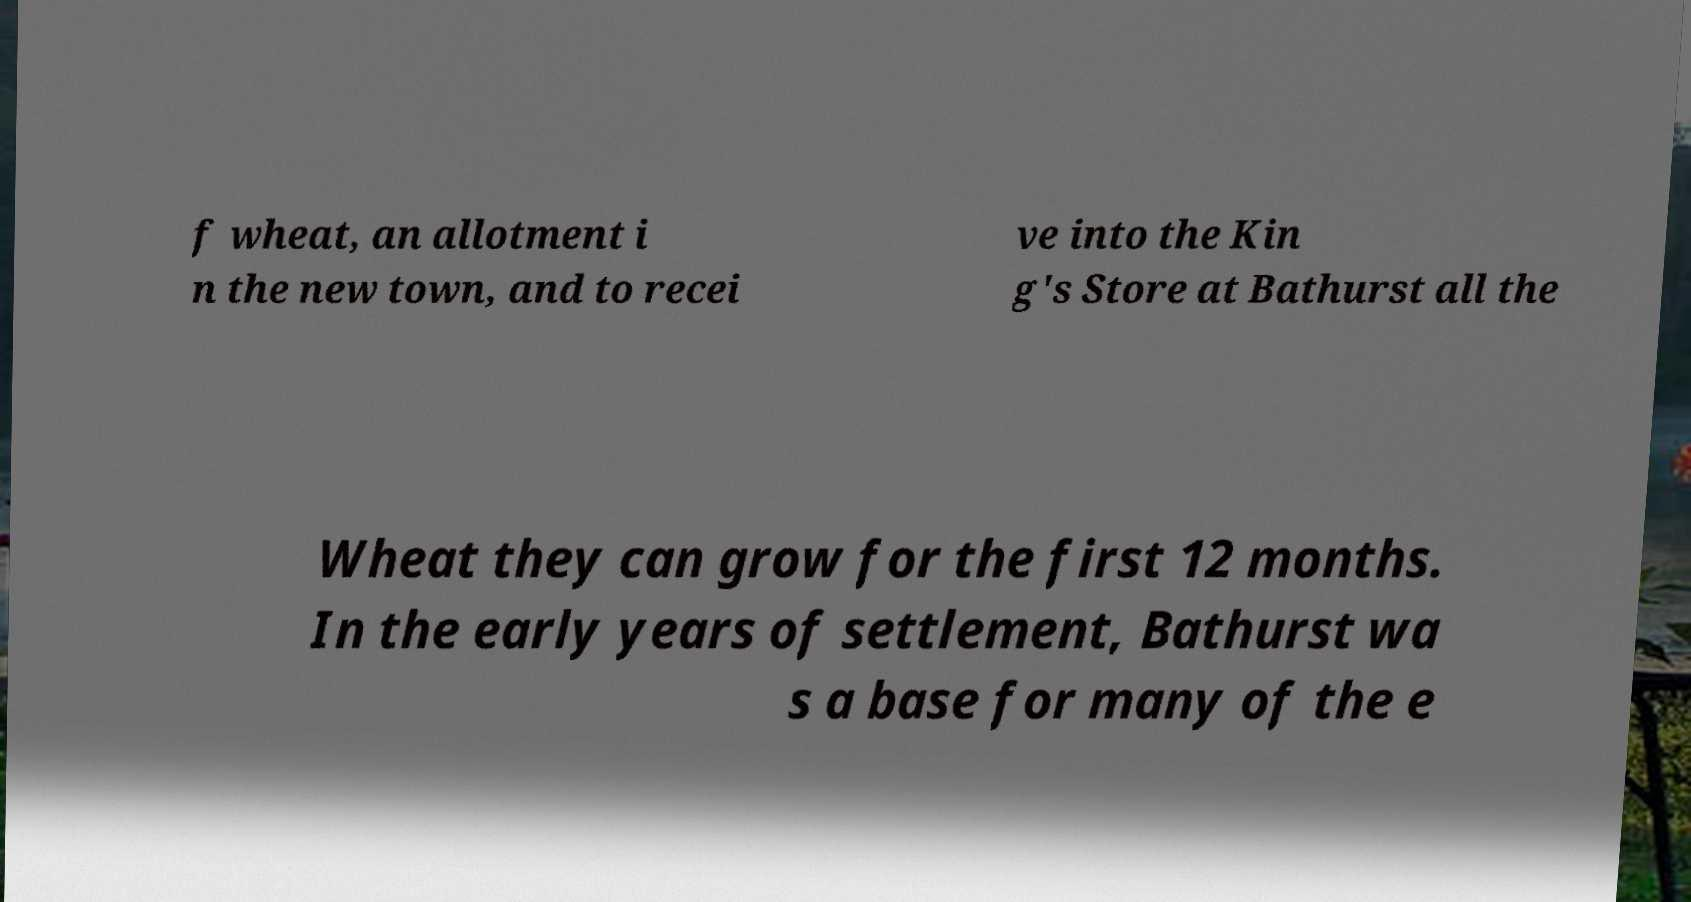Please read and relay the text visible in this image. What does it say? f wheat, an allotment i n the new town, and to recei ve into the Kin g's Store at Bathurst all the Wheat they can grow for the first 12 months. In the early years of settlement, Bathurst wa s a base for many of the e 